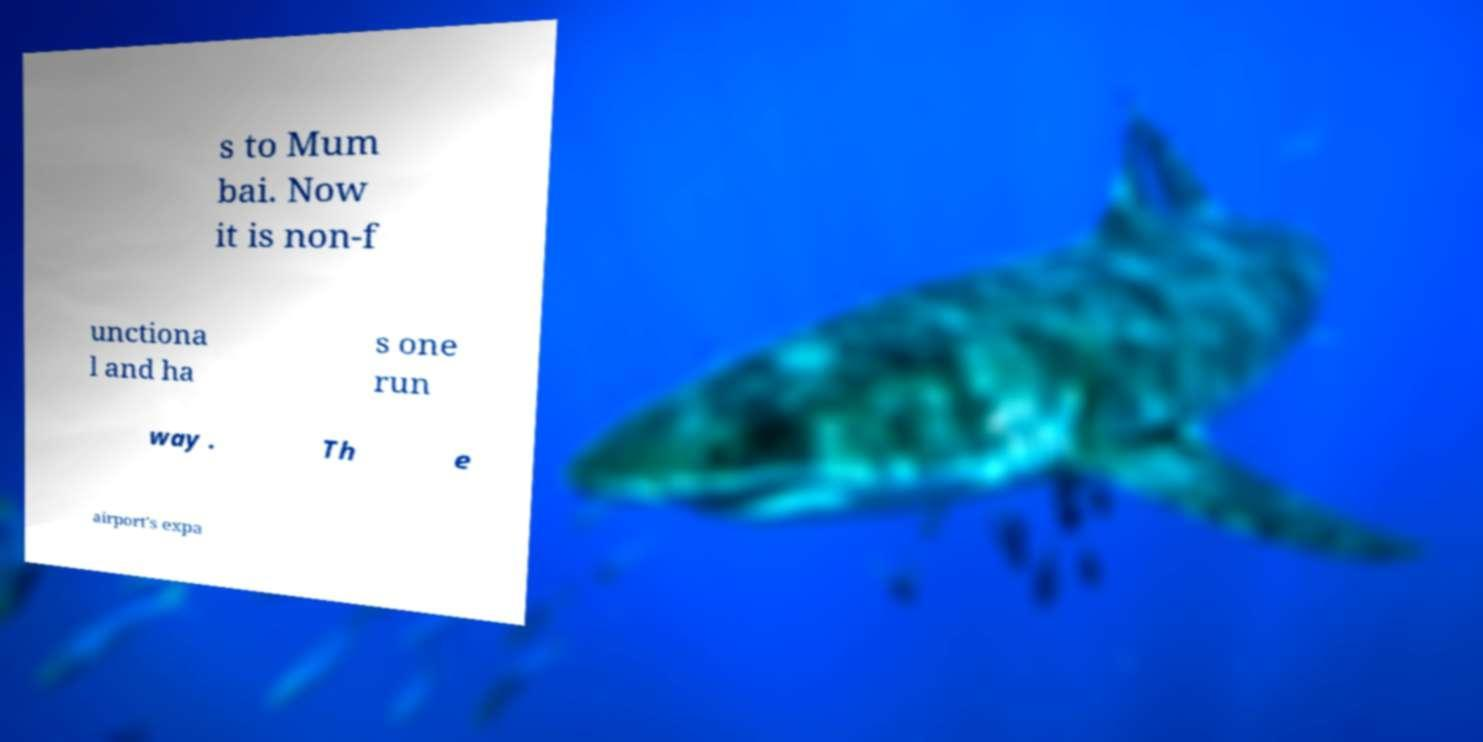Could you extract and type out the text from this image? s to Mum bai. Now it is non-f unctiona l and ha s one run way . Th e airport's expa 